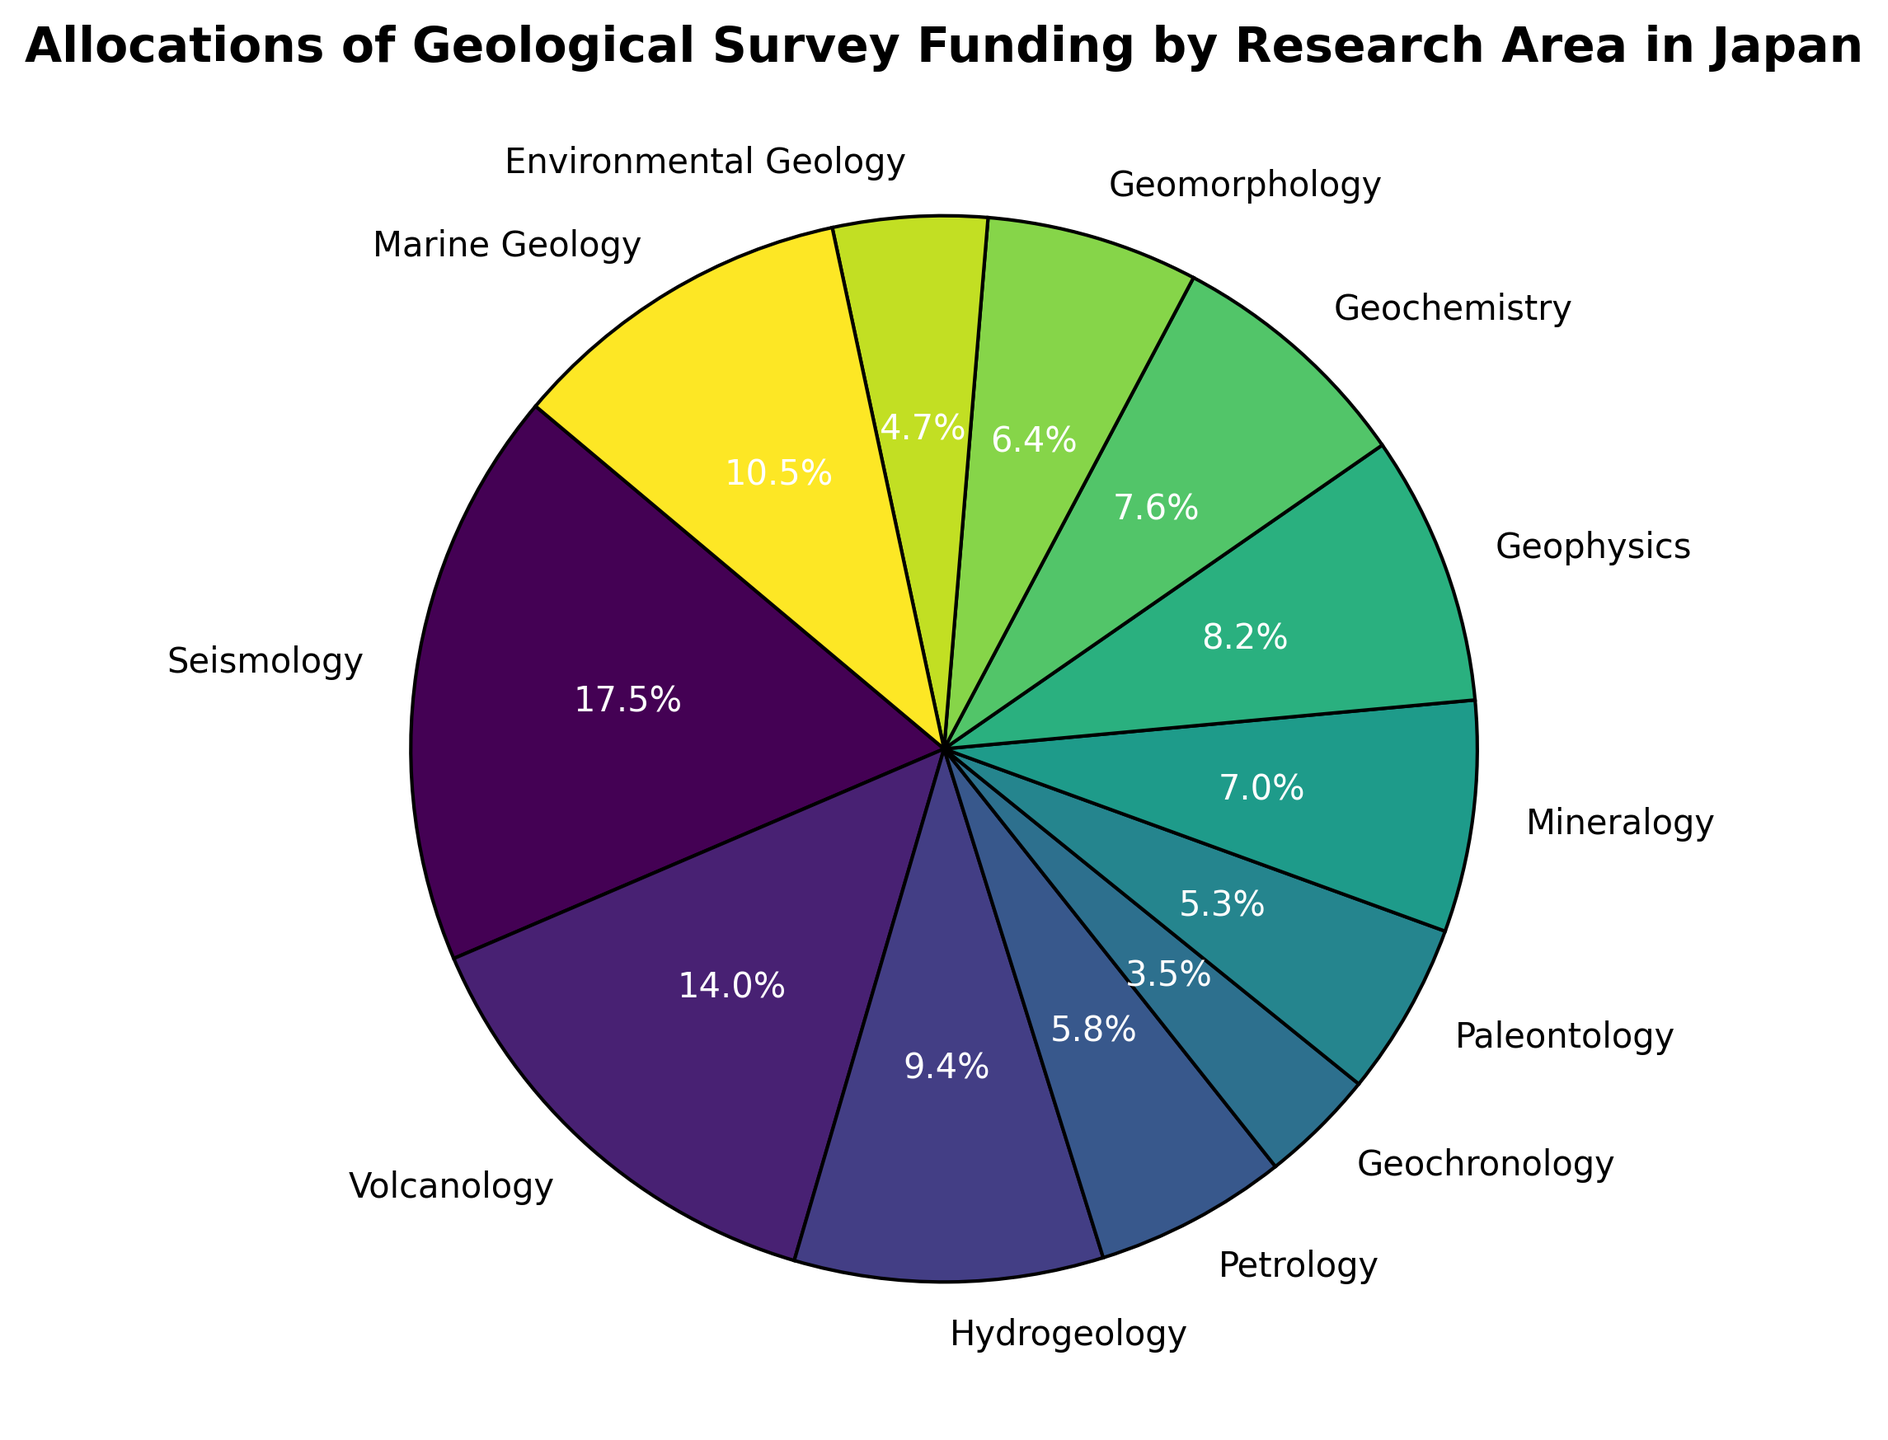What percentage of funding is allocated to Seismology and Volcanology combined? First, identify the percentage for Seismology (1500 million yen) and Volcanology (1200 million yen). Sum the values (1500 + 1200 = 2700 million yen). Then, calculate the total funding by summing all allocated funds. Finally, compute the percentage: (2700 / Total Funding) * 100.
Answer: 29.7% Which research area has the highest allocation, and how much is it? Examine the pie chart to identify which segment occupies the largest area. Compare the allocated values to find the highest. Seismology, with 1500 million yen, is the highest.
Answer: Seismology with 1500 million yen Compare the funding between Geophysics and Geochemistry. Which area gets more funding, and by how much? Locate the segments for Geophysics (700 million yen) and Geochemistry (650 million yen) in the pie chart. The difference in funding is calculated by subtracting the smaller allocation from the larger one: 700 - 650 = 50 million yen.
Answer: Geophysics by 50 million yen What is the difference in funding between the three smallest research areas? Identify the three smallest segments in the pie chart: Geochronology (300 million yen), Paleontology (450 million yen), and Environmental Geology (400 million yen). Calculate the differences between them: 450 - 300 = 150 million yen, and 450 - 400 = 50 million yen.
Answer: 150 million yen and 50 million yen Which research area has an allocation closest to 10% of the total funding? Calculate 10% of the total funding by summing all allocated amounts. Identify the research area whose allocation (as a percentage) is closest to this calculated value by examining the pie chart.
Answer: Marine Geology Determine the combined percentage of funding allocated to Mineralogy, Geophysics, and Geochemistry. Sum the funds for Mineralogy (600 million yen), Geophysics (700 million yen), and Geochemistry (650 million yen). Calculate the combined percentage: ((600 + 700 + 650) / Total Funding) * 100.
Answer: 22.2% What color represents the Volcanology segment? Observe the pie chart's color distribution and identify the color associated with Volcanology, which is labeled accordingly.
Answer: Green Is the allocation for Marine Geology more than the combined allocation for Environmental Geology and Geochronology? Compare Marine Geology (900 million yen) with the combined allocation of Environmental Geology (400 million yen) and Geochronology (300 million yen). Sum the two smaller allocations (400 + 300 = 700 million yen) and determine if 900 is greater than 700.
Answer: Yes Which research area has a slice between the colors corresponding to Geochronology and Volcanology? Identify the colors associated with Geochronology and Volcanology. Look for the segment located between these two colors on the pie chart.
Answer: Paleontology 